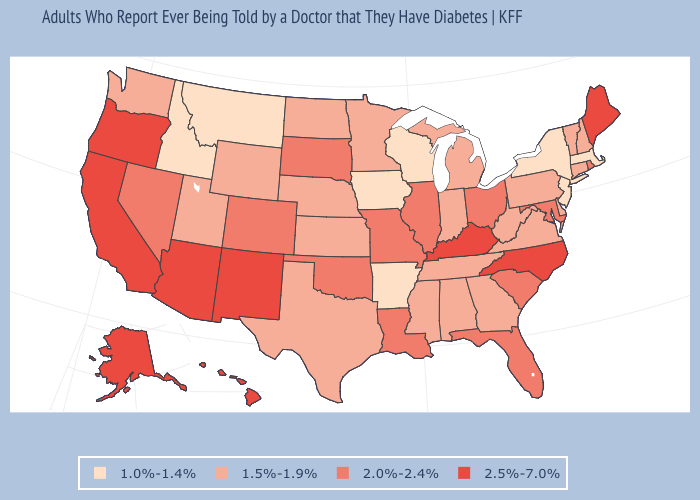Among the states that border Pennsylvania , does New Jersey have the lowest value?
Be succinct. Yes. What is the value of Vermont?
Write a very short answer. 1.5%-1.9%. What is the highest value in the West ?
Quick response, please. 2.5%-7.0%. What is the lowest value in the MidWest?
Quick response, please. 1.0%-1.4%. What is the highest value in the USA?
Write a very short answer. 2.5%-7.0%. Does Vermont have the lowest value in the USA?
Keep it brief. No. What is the lowest value in the South?
Short answer required. 1.0%-1.4%. Name the states that have a value in the range 2.0%-2.4%?
Give a very brief answer. Colorado, Florida, Illinois, Louisiana, Maryland, Missouri, Nevada, Ohio, Oklahoma, Rhode Island, South Carolina, South Dakota. Which states have the highest value in the USA?
Give a very brief answer. Alaska, Arizona, California, Hawaii, Kentucky, Maine, New Mexico, North Carolina, Oregon. Name the states that have a value in the range 1.0%-1.4%?
Give a very brief answer. Arkansas, Idaho, Iowa, Massachusetts, Montana, New Jersey, New York, Wisconsin. Does Delaware have the lowest value in the South?
Short answer required. No. Does the map have missing data?
Keep it brief. No. Does the map have missing data?
Quick response, please. No. What is the value of Florida?
Give a very brief answer. 2.0%-2.4%. Does the map have missing data?
Concise answer only. No. 